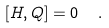Convert formula to latex. <formula><loc_0><loc_0><loc_500><loc_500>[ H , Q ] = 0 \ \ .</formula> 